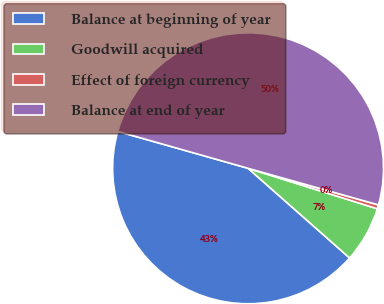<chart> <loc_0><loc_0><loc_500><loc_500><pie_chart><fcel>Balance at beginning of year<fcel>Goodwill acquired<fcel>Effect of foreign currency<fcel>Balance at end of year<nl><fcel>42.88%<fcel>6.68%<fcel>0.48%<fcel>49.96%<nl></chart> 